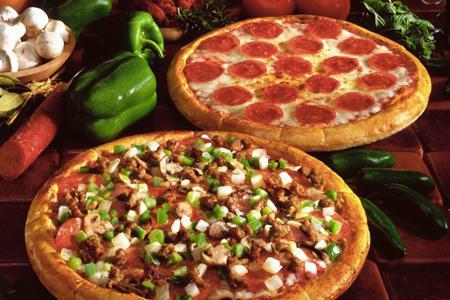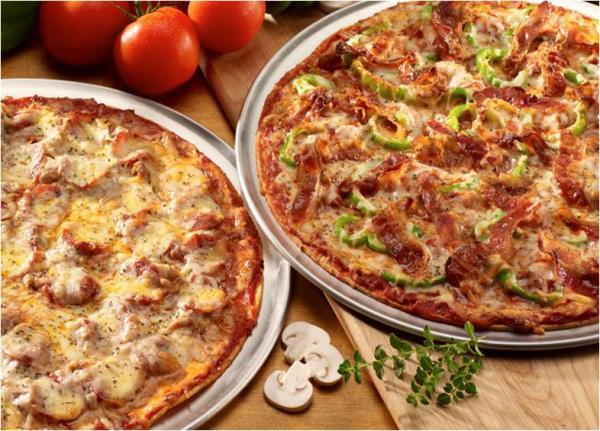The first image is the image on the left, the second image is the image on the right. Considering the images on both sides, is "The left image shows one round sliced pizza with a single slice out of place, and the right image contains more than one plate of food, including a pizza with green slices on top." valid? Answer yes or no. No. The first image is the image on the left, the second image is the image on the right. Assess this claim about the two images: "Exactly one pizza has green peppers on it.". Correct or not? Answer yes or no. No. 